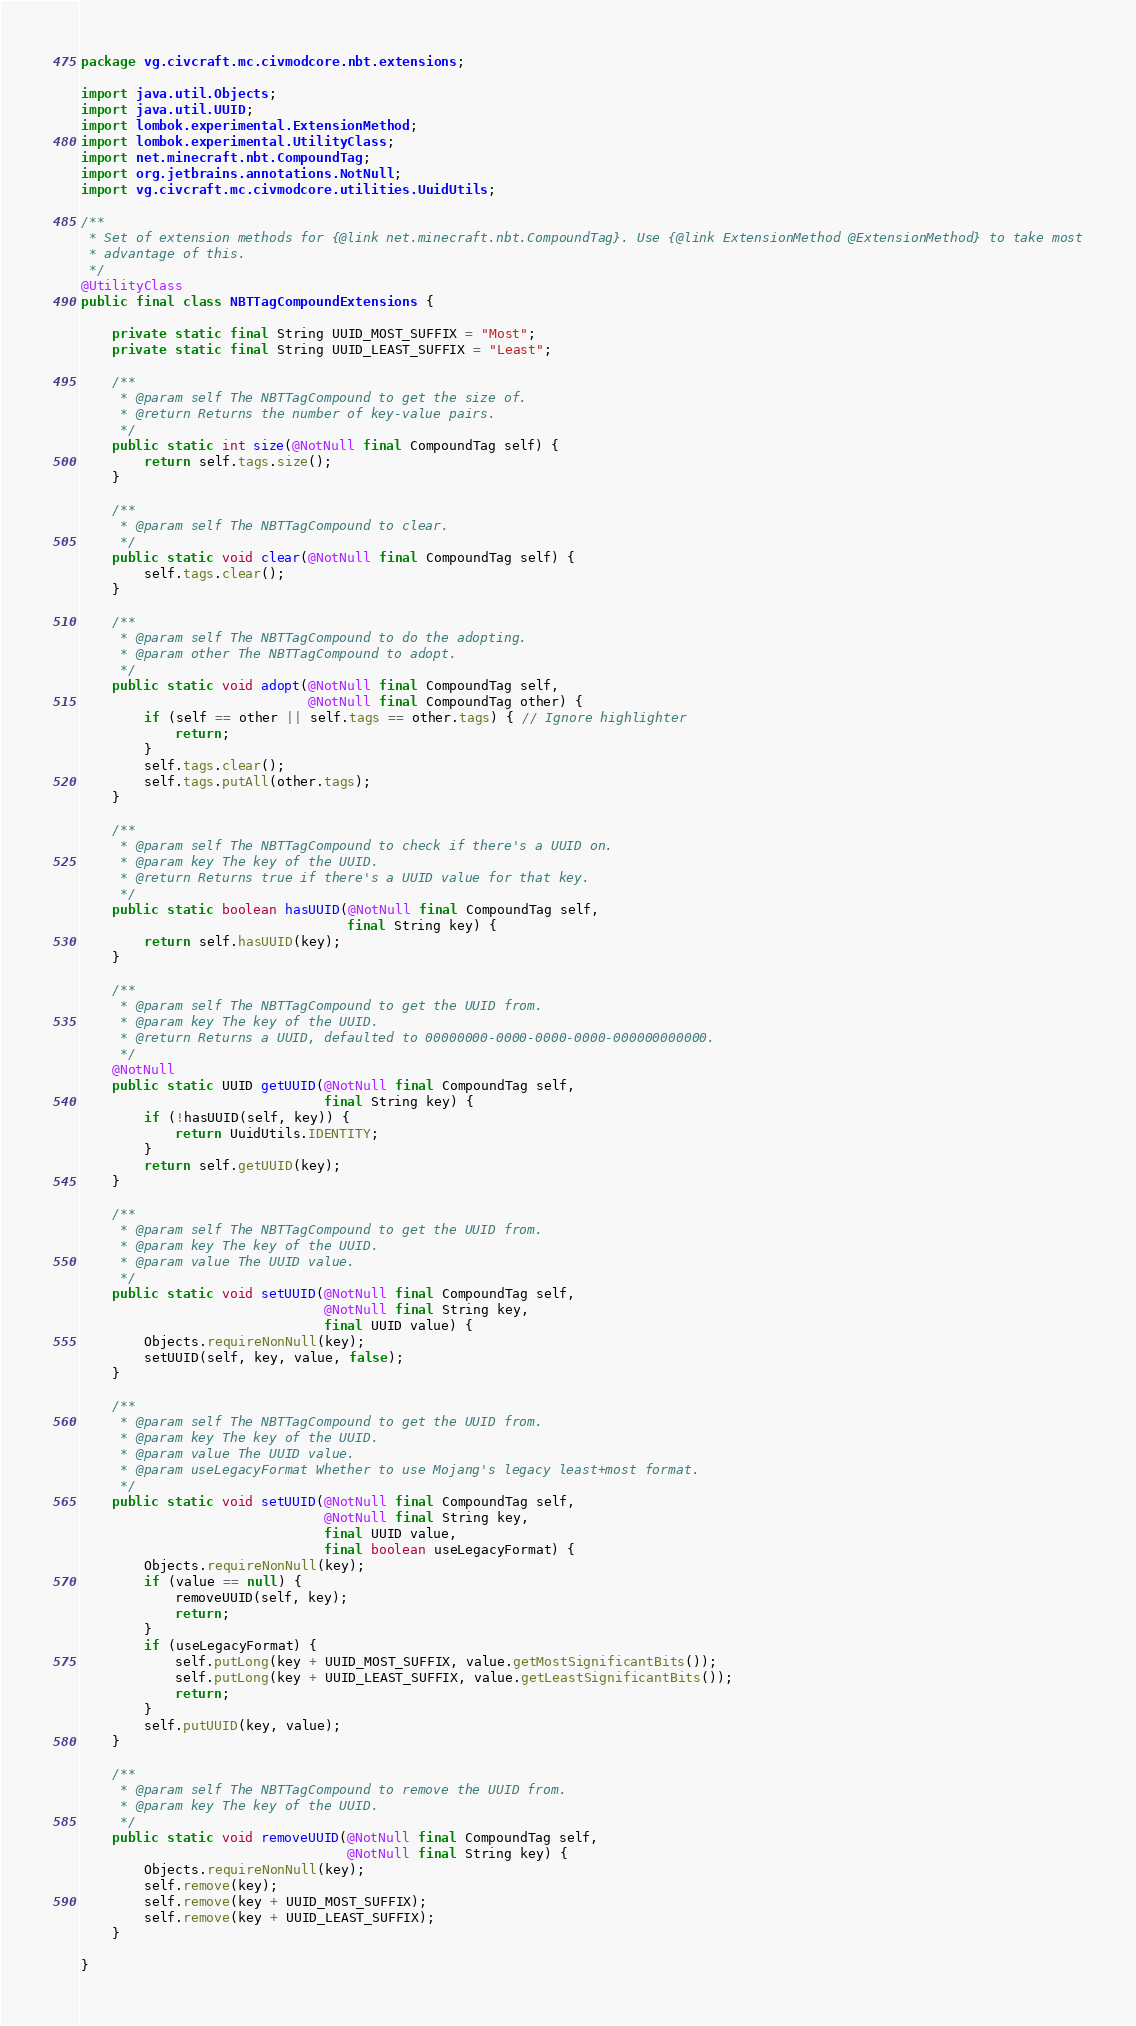Convert code to text. <code><loc_0><loc_0><loc_500><loc_500><_Java_>package vg.civcraft.mc.civmodcore.nbt.extensions;

import java.util.Objects;
import java.util.UUID;
import lombok.experimental.ExtensionMethod;
import lombok.experimental.UtilityClass;
import net.minecraft.nbt.CompoundTag;
import org.jetbrains.annotations.NotNull;
import vg.civcraft.mc.civmodcore.utilities.UuidUtils;

/**
 * Set of extension methods for {@link net.minecraft.nbt.CompoundTag}. Use {@link ExtensionMethod @ExtensionMethod} to take most
 * advantage of this.
 */
@UtilityClass
public final class NBTTagCompoundExtensions {

	private static final String UUID_MOST_SUFFIX = "Most";
	private static final String UUID_LEAST_SUFFIX = "Least";

	/**
	 * @param self The NBTTagCompound to get the size of.
	 * @return Returns the number of key-value pairs.
	 */
	public static int size(@NotNull final CompoundTag self) {
		return self.tags.size();
	}

	/**
	 * @param self The NBTTagCompound to clear.
	 */
	public static void clear(@NotNull final CompoundTag self) {
		self.tags.clear();
	}

	/**
	 * @param self The NBTTagCompound to do the adopting.
	 * @param other The NBTTagCompound to adopt.
	 */
	public static void adopt(@NotNull final CompoundTag self,
							 @NotNull final CompoundTag other) {
		if (self == other || self.tags == other.tags) { // Ignore highlighter
			return;
		}
		self.tags.clear();
		self.tags.putAll(other.tags);
	}

	/**
	 * @param self The NBTTagCompound to check if there's a UUID on.
	 * @param key The key of the UUID.
	 * @return Returns true if there's a UUID value for that key.
	 */
	public static boolean hasUUID(@NotNull final CompoundTag self,
								  final String key) {
		return self.hasUUID(key);
	}

	/**
	 * @param self The NBTTagCompound to get the UUID from.
	 * @param key The key of the UUID.
	 * @return Returns a UUID, defaulted to 00000000-0000-0000-0000-000000000000.
	 */
	@NotNull
	public static UUID getUUID(@NotNull final CompoundTag self,
							   final String key) {
		if (!hasUUID(self, key)) {
			return UuidUtils.IDENTITY;
		}
		return self.getUUID(key);
	}

	/**
	 * @param self The NBTTagCompound to get the UUID from.
	 * @param key The key of the UUID.
	 * @param value The UUID value.
	 */
	public static void setUUID(@NotNull final CompoundTag self,
							   @NotNull final String key,
							   final UUID value) {
		Objects.requireNonNull(key);
		setUUID(self, key, value, false);
	}

	/**
	 * @param self The NBTTagCompound to get the UUID from.
	 * @param key The key of the UUID.
	 * @param value The UUID value.
	 * @param useLegacyFormat Whether to use Mojang's legacy least+most format.
	 */
	public static void setUUID(@NotNull final CompoundTag self,
							   @NotNull final String key,
							   final UUID value,
							   final boolean useLegacyFormat) {
		Objects.requireNonNull(key);
		if (value == null) {
			removeUUID(self, key);
			return;
		}
		if (useLegacyFormat) {
			self.putLong(key + UUID_MOST_SUFFIX, value.getMostSignificantBits());
			self.putLong(key + UUID_LEAST_SUFFIX, value.getLeastSignificantBits());
			return;
		}
		self.putUUID(key, value);
	}

	/**
	 * @param self The NBTTagCompound to remove the UUID from.
	 * @param key The key of the UUID.
	 */
	public static void removeUUID(@NotNull final CompoundTag self,
								  @NotNull final String key) {
		Objects.requireNonNull(key);
		self.remove(key);
		self.remove(key + UUID_MOST_SUFFIX);
		self.remove(key + UUID_LEAST_SUFFIX);
	}

}
</code> 